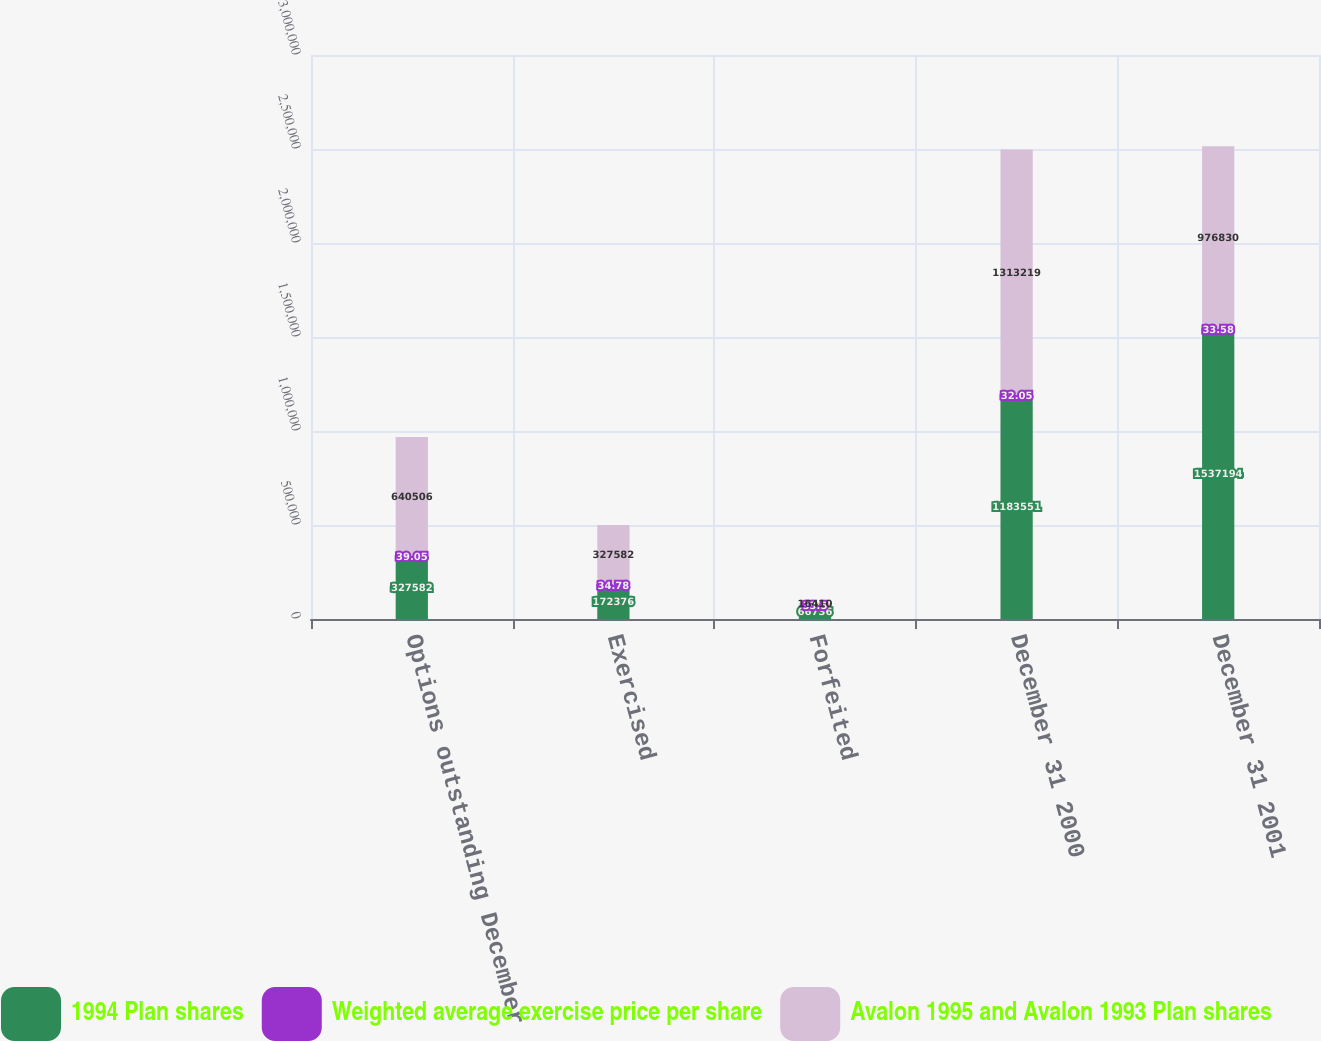Convert chart to OTSL. <chart><loc_0><loc_0><loc_500><loc_500><stacked_bar_chart><ecel><fcel>Options outstanding December<fcel>Exercised<fcel>Forfeited<fcel>December 31 2000<fcel>December 31 2001<nl><fcel>1994 Plan shares<fcel>327582<fcel>172376<fcel>66736<fcel>1.18355e+06<fcel>1.53719e+06<nl><fcel>Weighted average exercise price per share<fcel>39.05<fcel>34.78<fcel>33.5<fcel>32.05<fcel>33.58<nl><fcel>Avalon 1995 and Avalon 1993 Plan shares<fcel>640506<fcel>327582<fcel>16410<fcel>1.31322e+06<fcel>976830<nl></chart> 